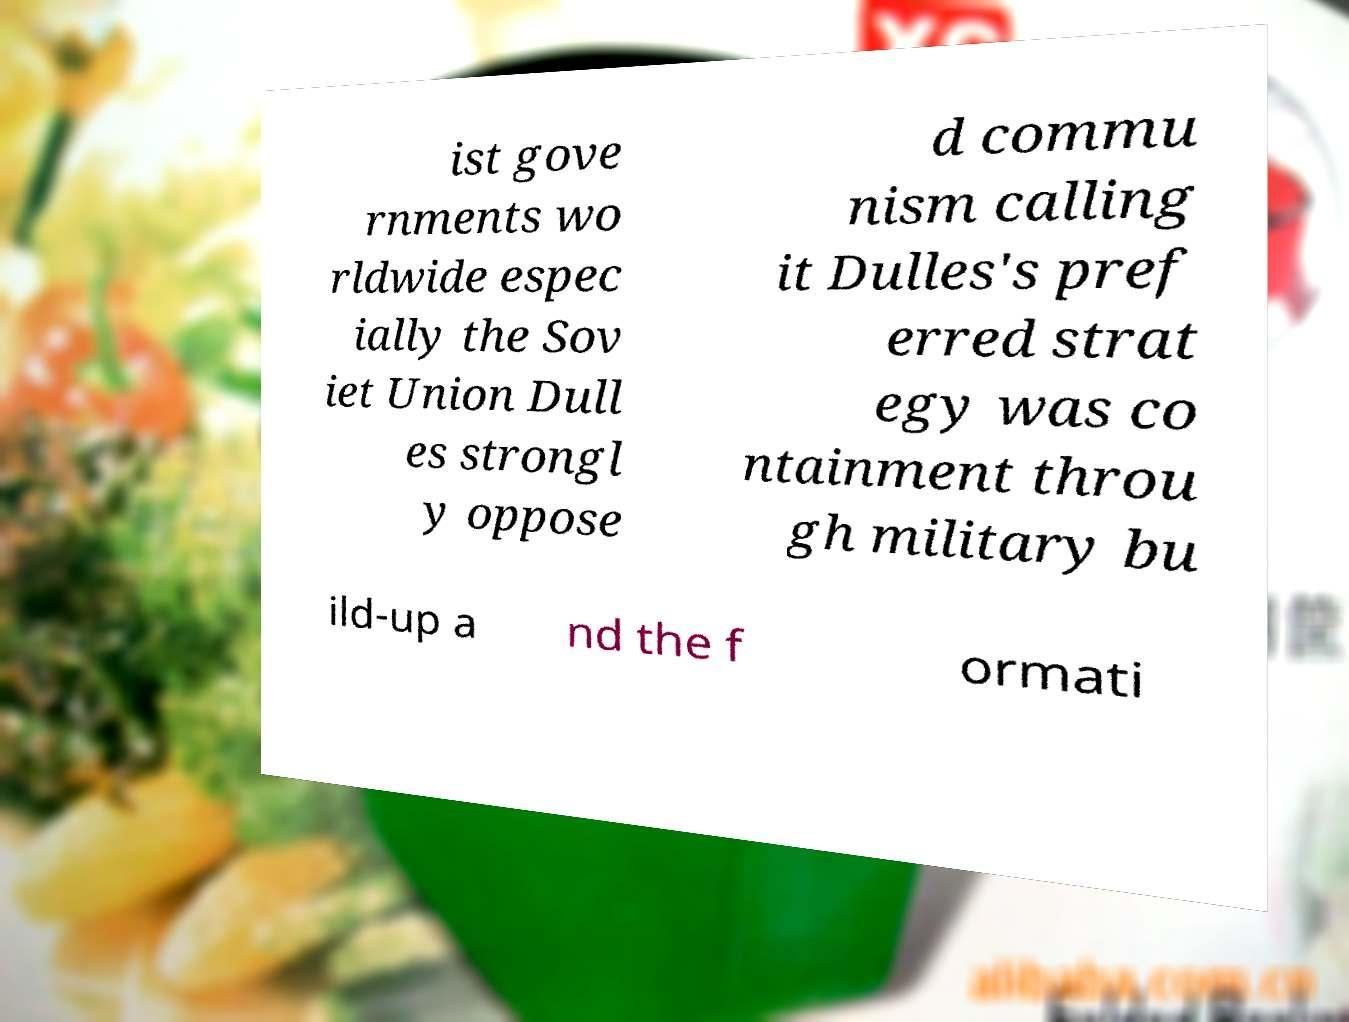What messages or text are displayed in this image? I need them in a readable, typed format. ist gove rnments wo rldwide espec ially the Sov iet Union Dull es strongl y oppose d commu nism calling it Dulles's pref erred strat egy was co ntainment throu gh military bu ild-up a nd the f ormati 